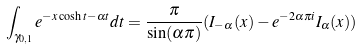<formula> <loc_0><loc_0><loc_500><loc_500>\int _ { \gamma _ { 0 , 1 } } e ^ { - x \cosh t - \alpha t } d t = \frac { \pi } { \sin ( \alpha \pi ) } ( I _ { - \alpha } ( x ) - e ^ { - 2 \alpha \pi i } I _ { \alpha } ( x ) )</formula> 